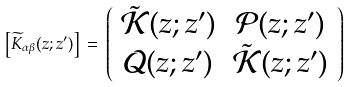<formula> <loc_0><loc_0><loc_500><loc_500>\left [ { \widetilde { K } } _ { \alpha \beta } ( z ; z ^ { \prime } ) \right ] \, = \, \left ( \begin{array} { c c } \tilde { \mathcal { K } } ( z ; z ^ { \prime } ) & { \mathcal { P } } ( z ; z ^ { \prime } ) \\ { \mathcal { Q } } ( z ; z ^ { \prime } ) & \tilde { \mathcal { K } } ( z ; z ^ { \prime } ) \end{array} \right )</formula> 